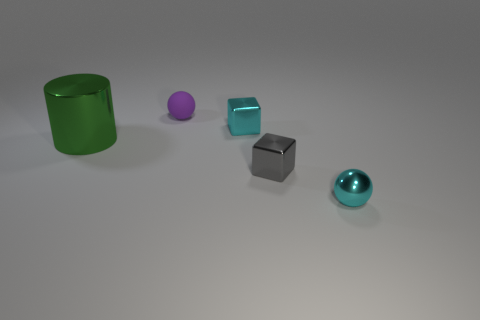Is the size of the gray object the same as the cyan ball?
Offer a terse response. Yes. How big is the metal object that is both on the left side of the small cyan sphere and to the right of the tiny cyan shiny block?
Offer a terse response. Small. What number of matte things are large brown things or tiny cyan blocks?
Provide a succinct answer. 0. Is the number of tiny cyan blocks on the right side of the cyan cube greater than the number of tiny cyan metallic objects?
Keep it short and to the point. No. What material is the tiny cyan block to the right of the green metallic thing?
Keep it short and to the point. Metal. How many tiny cubes have the same material as the large cylinder?
Your answer should be compact. 2. What is the shape of the thing that is in front of the rubber ball and to the left of the small cyan shiny block?
Offer a terse response. Cylinder. What number of objects are either tiny shiny things that are left of the gray thing or things that are in front of the small purple ball?
Your response must be concise. 4. Are there the same number of cyan metallic spheres on the left side of the large metal cylinder and tiny gray metal cubes that are behind the gray metal thing?
Your response must be concise. Yes. What is the shape of the small cyan object on the left side of the sphere that is in front of the cylinder?
Offer a very short reply. Cube. 